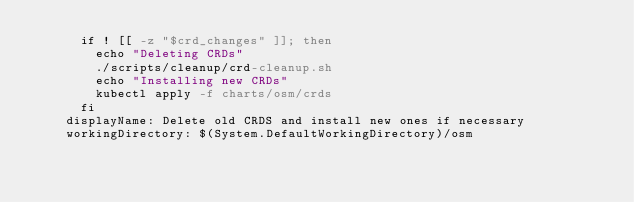<code> <loc_0><loc_0><loc_500><loc_500><_YAML_>      if ! [[ -z "$crd_changes" ]]; then
        echo "Deleting CRDs"
        ./scripts/cleanup/crd-cleanup.sh
        echo "Installing new CRDs"
        kubectl apply -f charts/osm/crds
      fi
    displayName: Delete old CRDS and install new ones if necessary
    workingDirectory: $(System.DefaultWorkingDirectory)/osm
</code> 